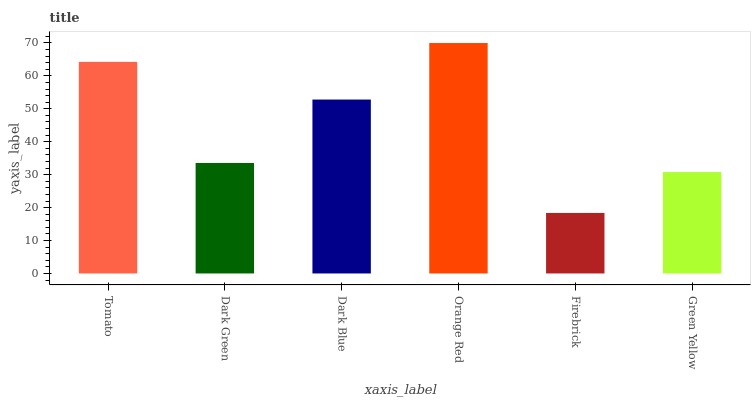Is Firebrick the minimum?
Answer yes or no. Yes. Is Orange Red the maximum?
Answer yes or no. Yes. Is Dark Green the minimum?
Answer yes or no. No. Is Dark Green the maximum?
Answer yes or no. No. Is Tomato greater than Dark Green?
Answer yes or no. Yes. Is Dark Green less than Tomato?
Answer yes or no. Yes. Is Dark Green greater than Tomato?
Answer yes or no. No. Is Tomato less than Dark Green?
Answer yes or no. No. Is Dark Blue the high median?
Answer yes or no. Yes. Is Dark Green the low median?
Answer yes or no. Yes. Is Green Yellow the high median?
Answer yes or no. No. Is Orange Red the low median?
Answer yes or no. No. 